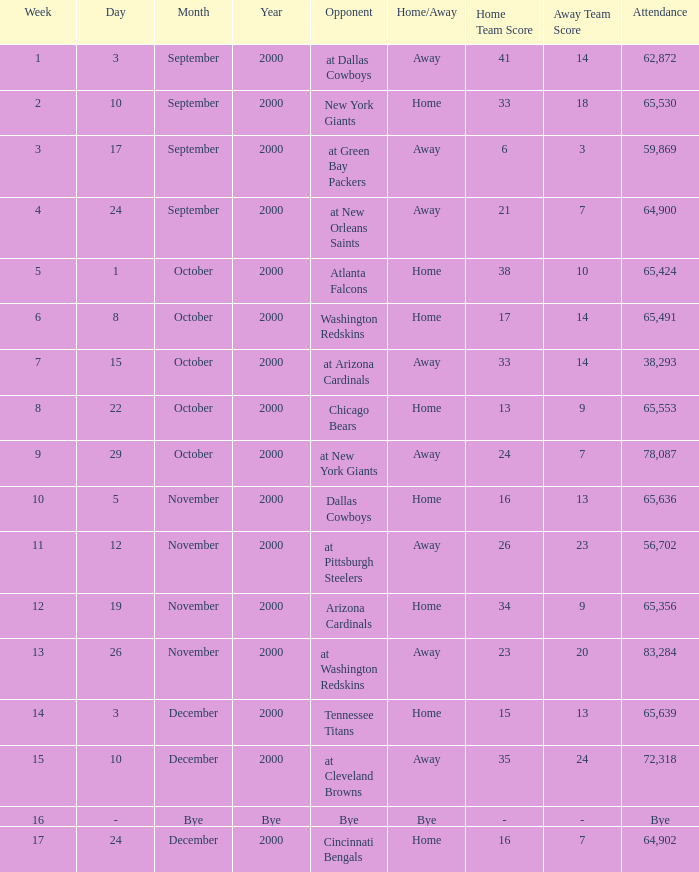What was the attendance for week 2? 65530.0. 